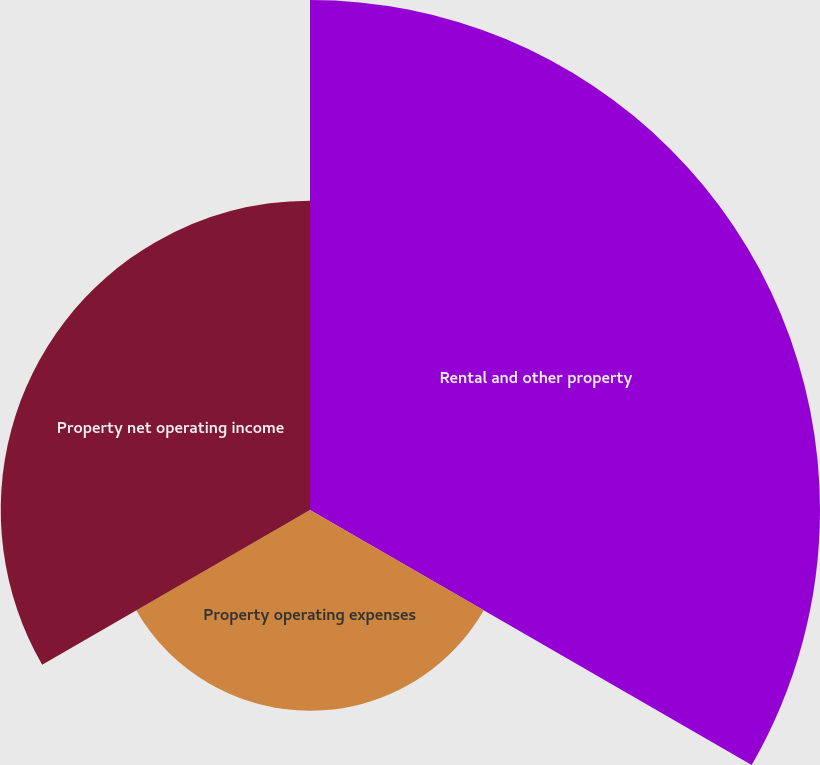<chart> <loc_0><loc_0><loc_500><loc_500><pie_chart><fcel>Rental and other property<fcel>Property operating expenses<fcel>Property net operating income<nl><fcel>50.0%<fcel>19.68%<fcel>30.32%<nl></chart> 